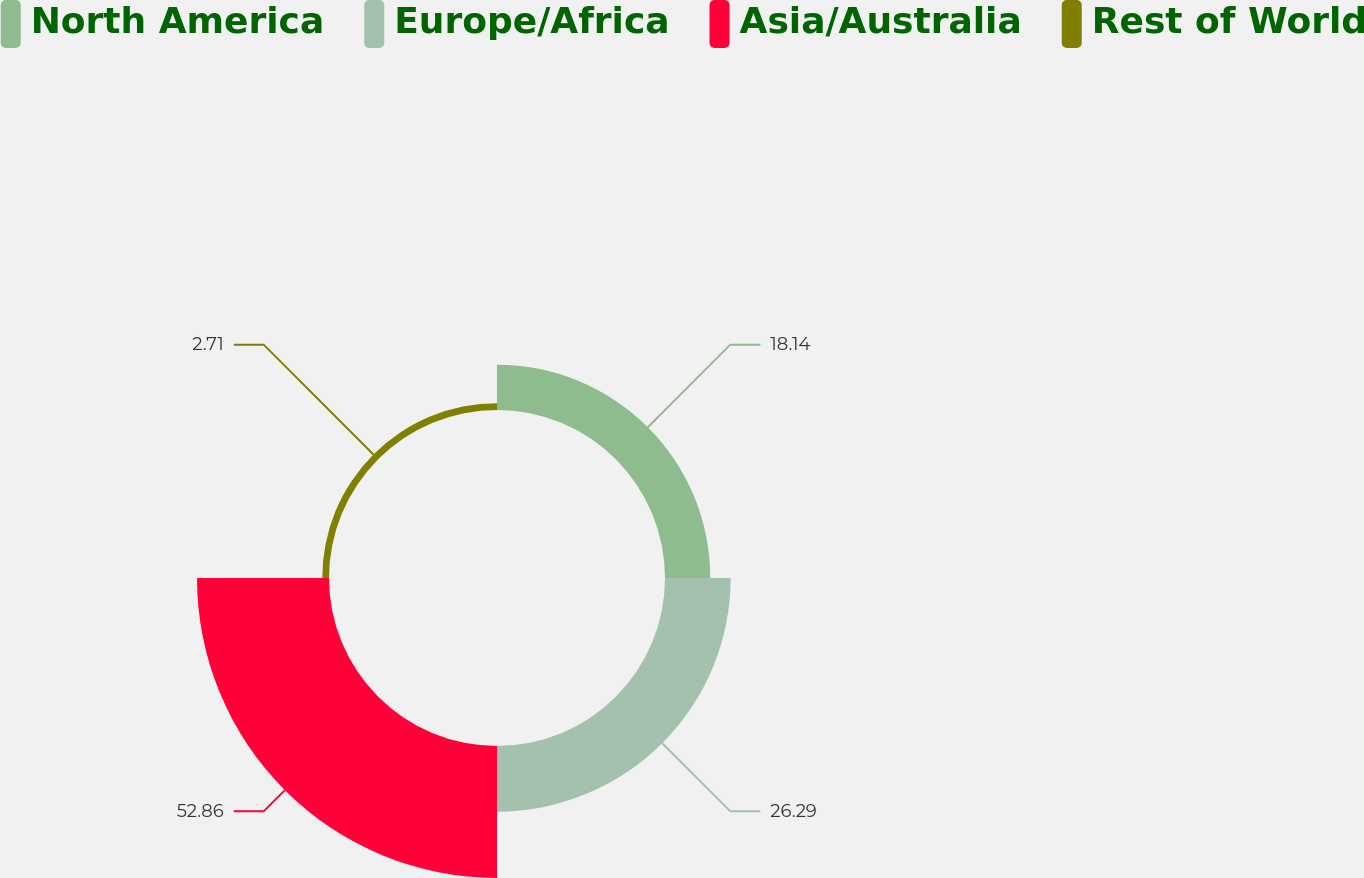Convert chart to OTSL. <chart><loc_0><loc_0><loc_500><loc_500><pie_chart><fcel>North America<fcel>Europe/Africa<fcel>Asia/Australia<fcel>Rest of World<nl><fcel>18.14%<fcel>26.29%<fcel>52.86%<fcel>2.71%<nl></chart> 